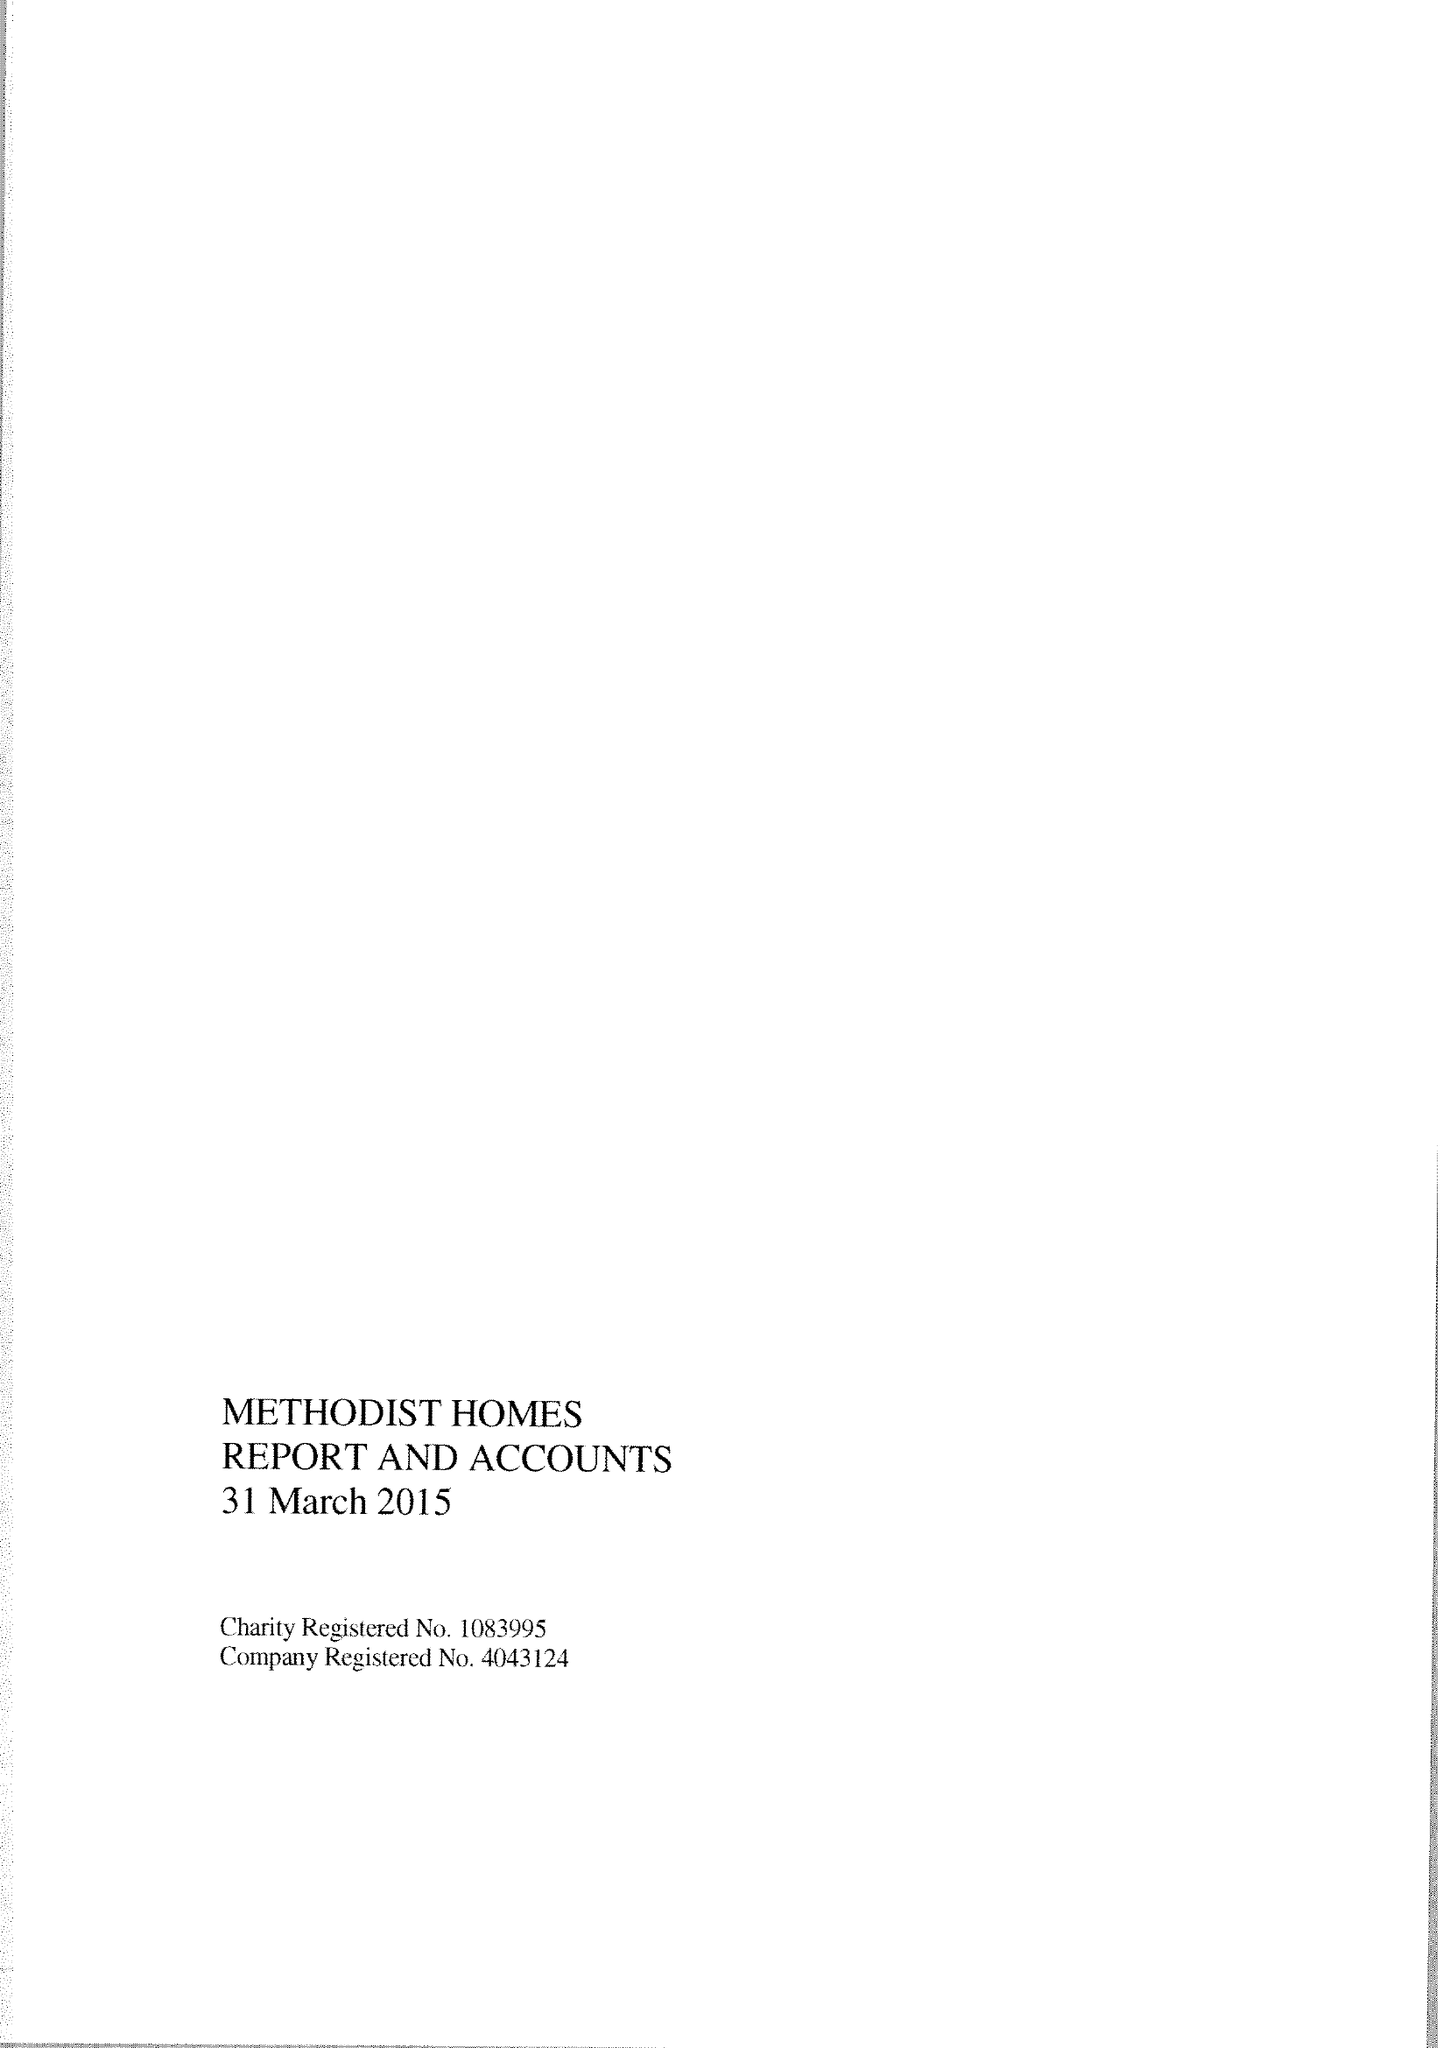What is the value for the address__post_town?
Answer the question using a single word or phrase. DERBY 